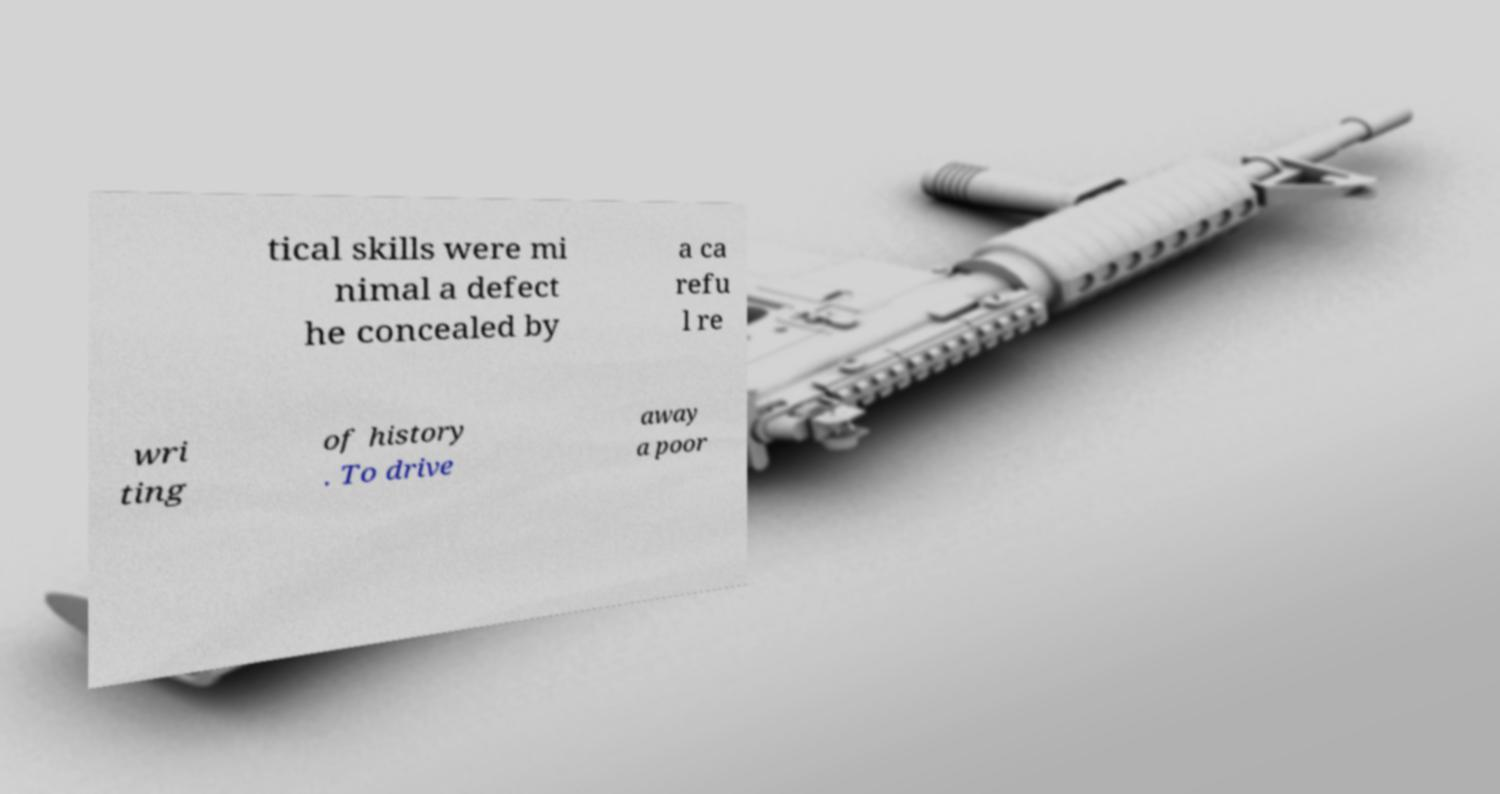Please identify and transcribe the text found in this image. tical skills were mi nimal a defect he concealed by a ca refu l re wri ting of history . To drive away a poor 